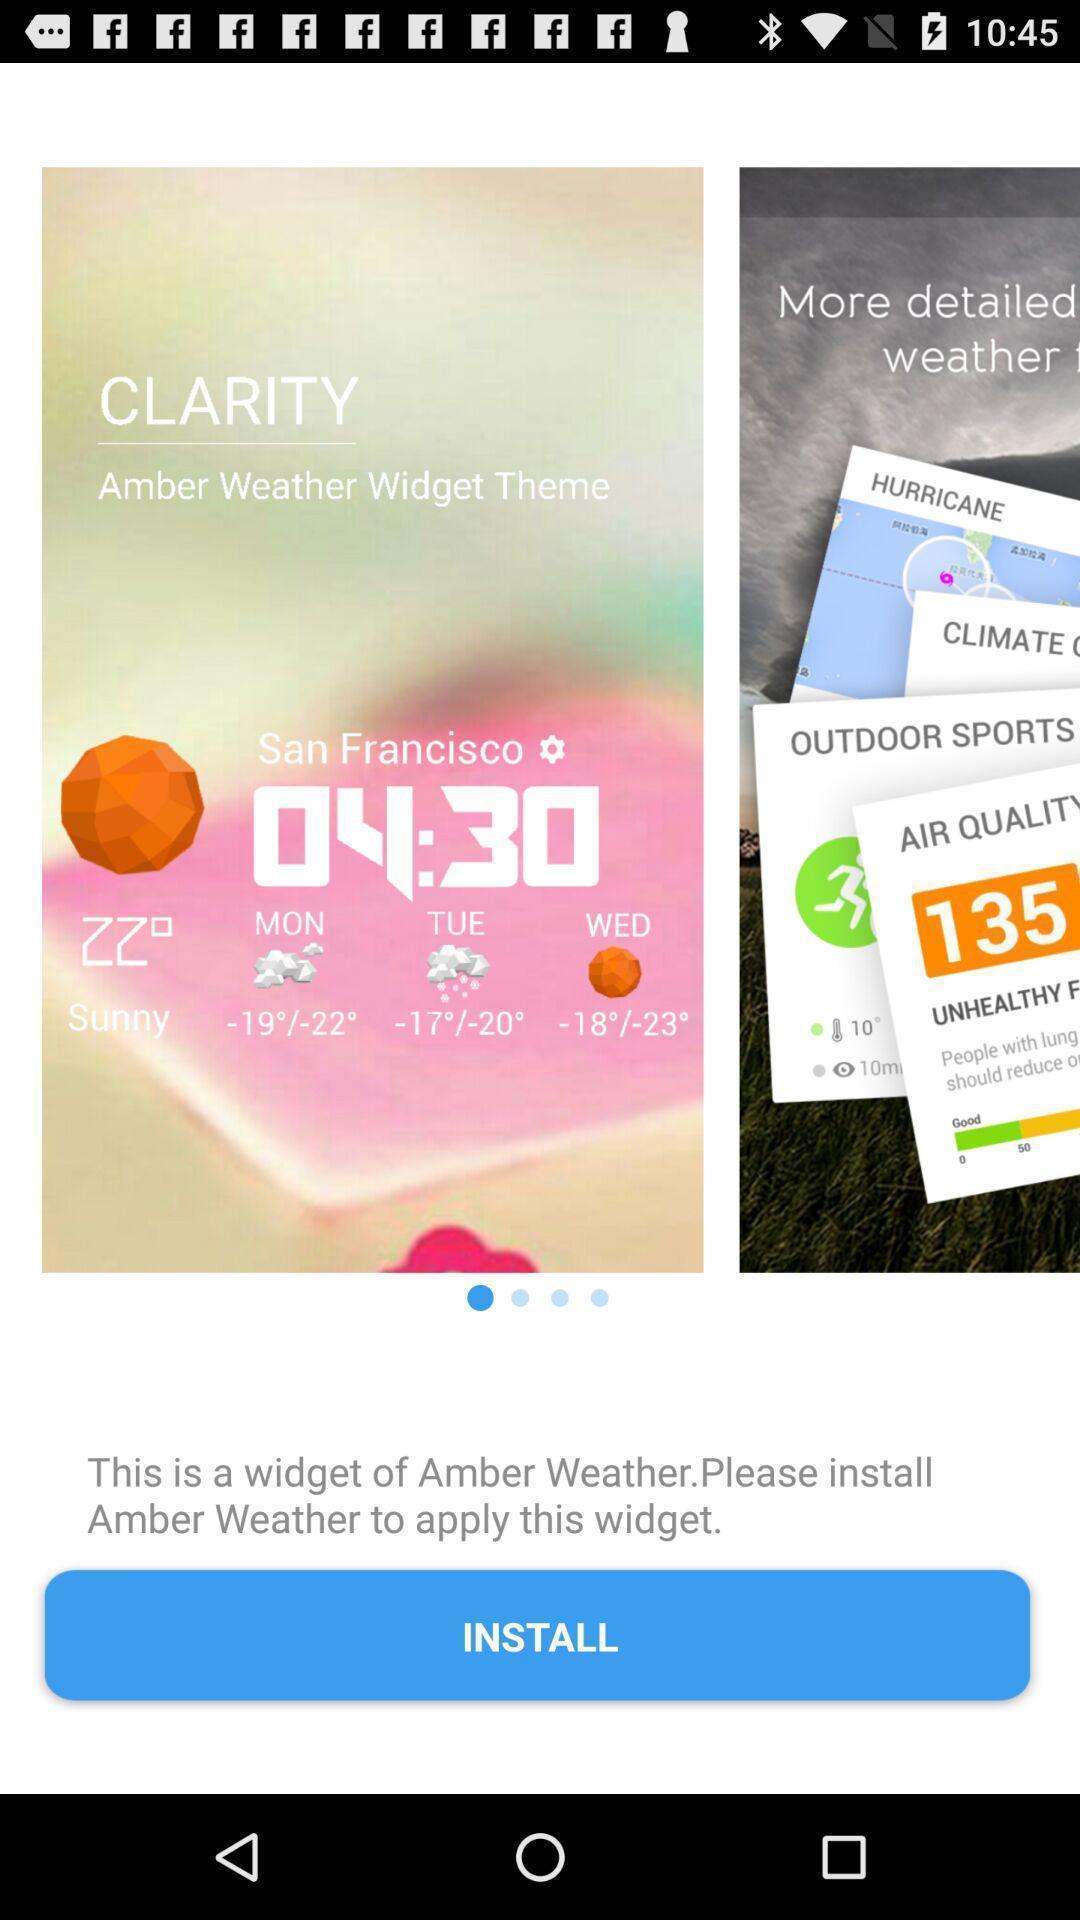Describe the visual elements of this screenshot. Page showing to install a clock and weather forecast app. 